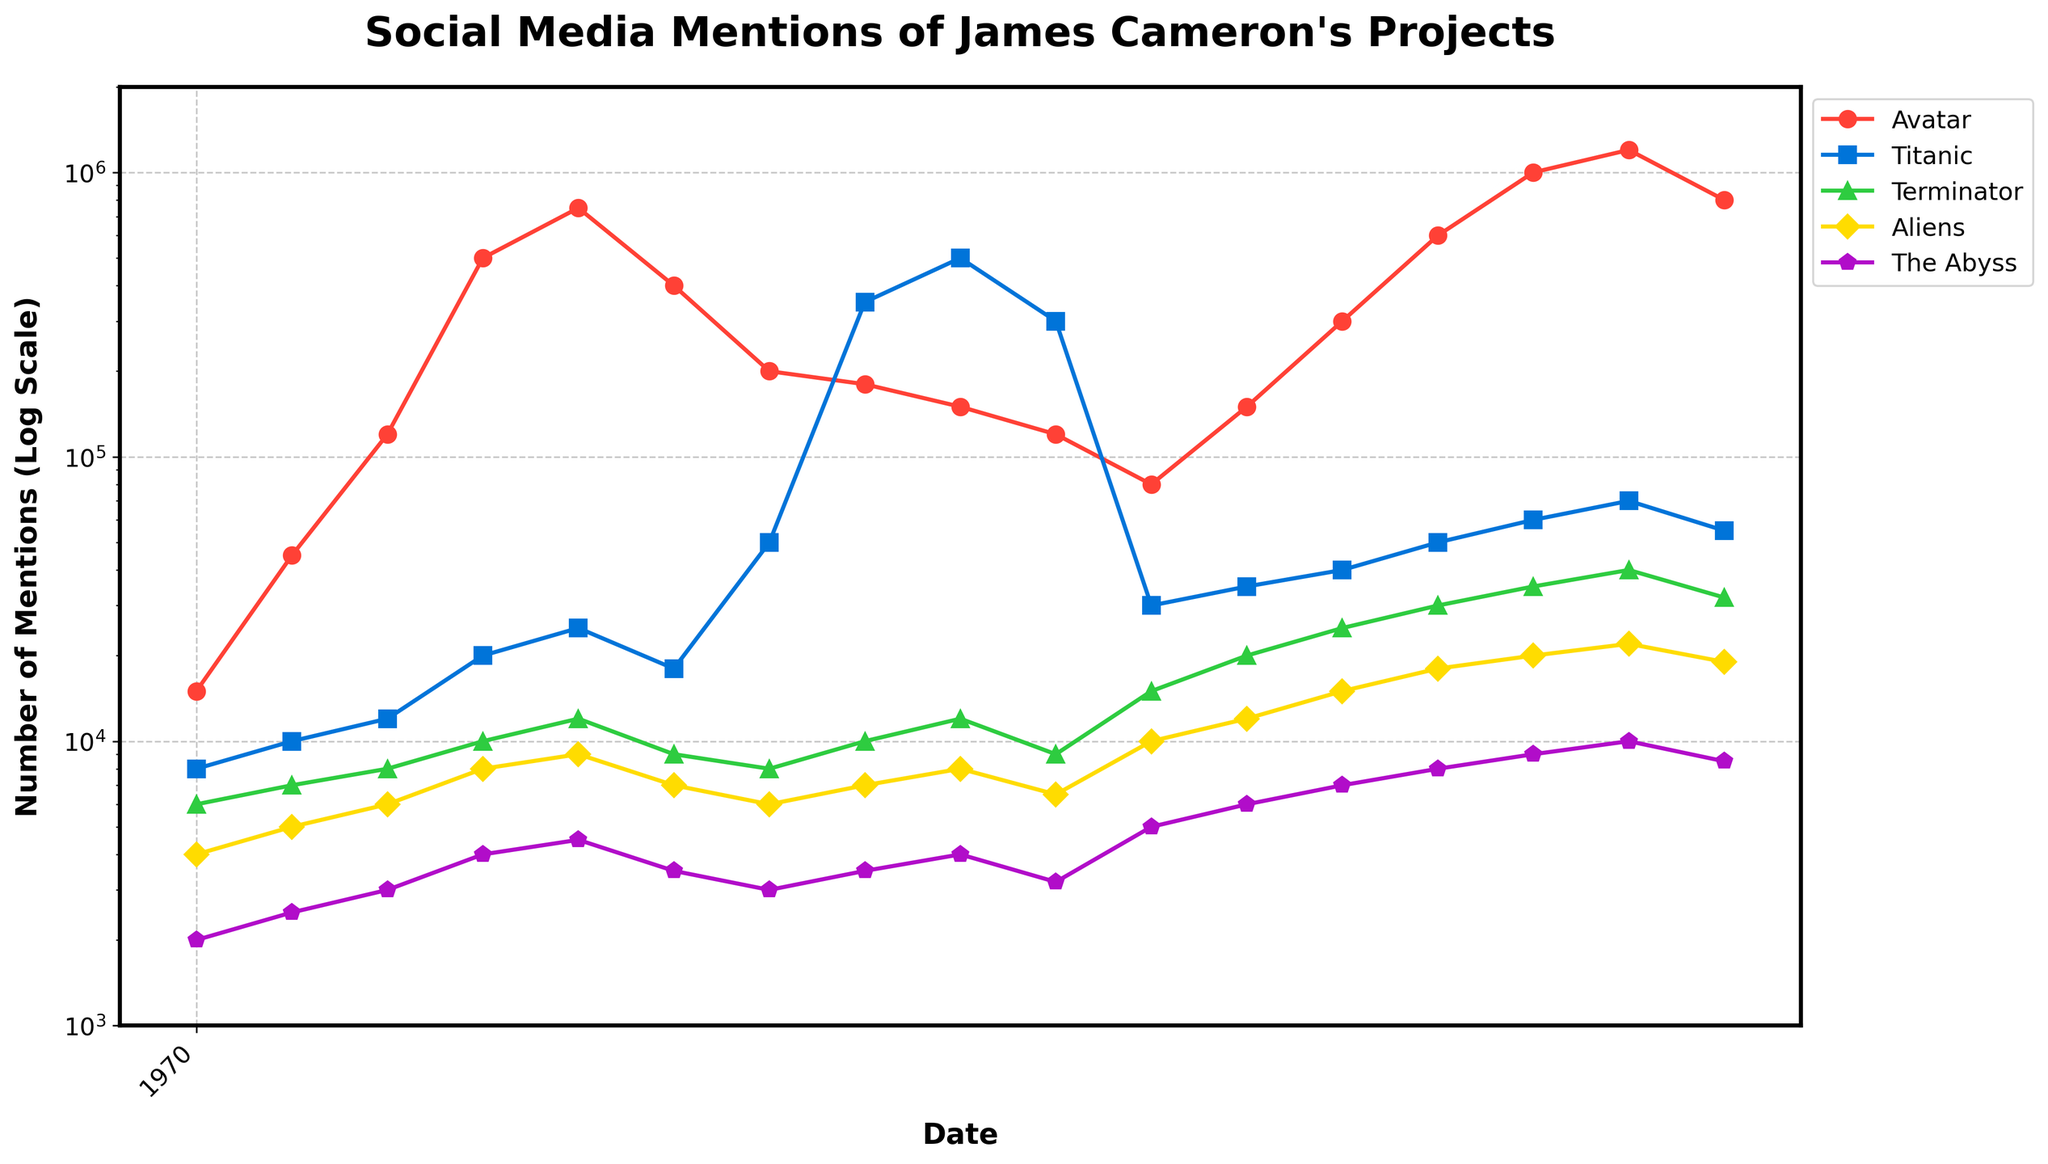what is the trend in social media mentions of "Avatar" from 2009 to 2010? The mentions of "Avatar" increased sharply from May 2009 (15,000) reaching peaks in December 2009 (500,000) and January 2010 (750,000), before slightly declining.
Answer: Increasing, then declining How do the social media mentions of "Titanic" compare to "The Abyss" on April 15, 2012? On April 15, 2012, "Titanic" had 500,000 mentions, while "The Abyss" only had 4,000 mentions.
Answer: Titanic has more mentions Which project experienced the largest spike in mentions, and when did it occur? "Avatar" experienced the largest spike, reaching 1,200,000 mentions in January 2023.
Answer: Avatar in January 2023 What is the average number of social media mentions for "Aliens" during 2012? The mentions for "Aliens" in 2012 are 7,000 (March), 7,000 (April 4th), 8,000 (April 15th), and 6,500 (May). The average is calculated as (7,000 + 7,000 + 8,000 + 6,500) / 4 = 7,125
Answer: 7,125 Between 2009 and 2023, in which period did "Terminator" have the highest number of mentions and what was the count? "Terminator" had the highest number of mentions in January 2023 with 40,000 mentions.
Answer: January 2023 with 40,000 mentions What difference can be seen in the social media mentions of "Titanic" from May 2009 to April 15, 2012? In May 2009, "Titanic" had 8,000 mentions. By April 15, 2012, mentions increased to 500,000, showing a significant rise.
Answer: Significant rise Which James Cameron project saw the most mentions over the entire period? "Avatar" consistently had higher mentions compared to the other projects, especially peaking in January 2023 with the highest count.
Answer: Avatar How do the mentions of "The Abyss" compare in January 2010 and January 2023? In January 2010, "The Abyss" had 4,500 mentions, whereas in January 2023, it had 10,000 mentions.
Answer: January 2023 has more What can be inferred about the mentions trend for "Avatar" after major releases? Following its release, "Avatar" saw significant spikes in mentions, notably in December 2009, and even more in December 2022 and January 2023.
Answer: Mentions spike after releases 